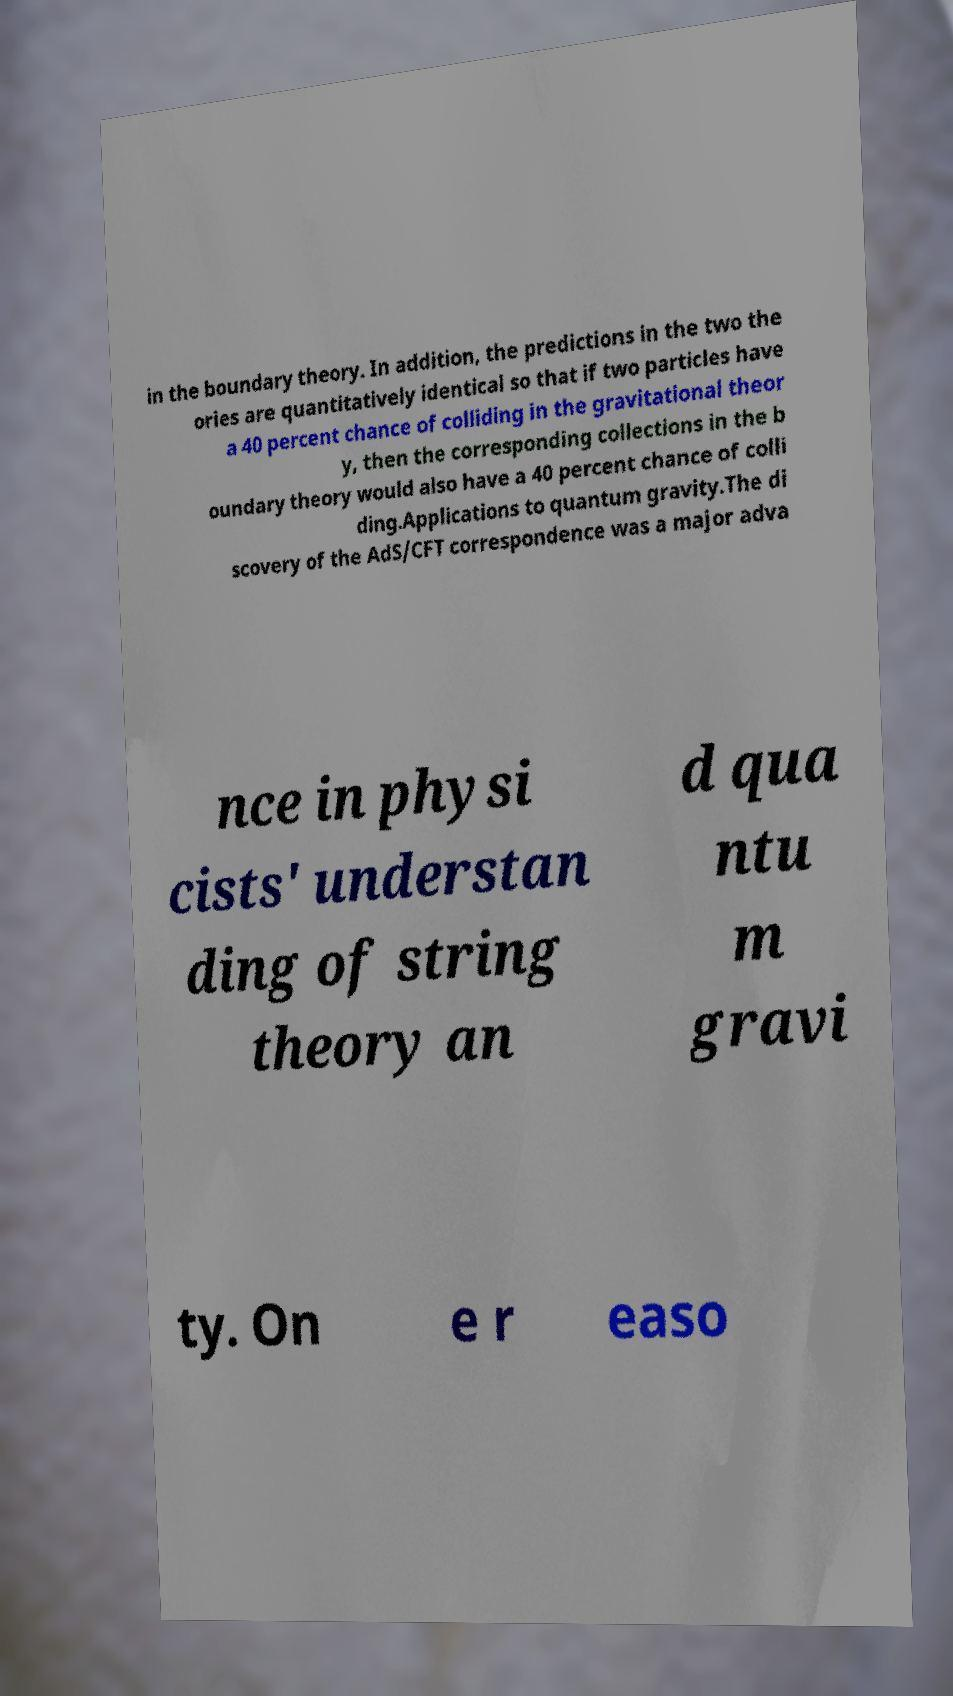Can you accurately transcribe the text from the provided image for me? in the boundary theory. In addition, the predictions in the two the ories are quantitatively identical so that if two particles have a 40 percent chance of colliding in the gravitational theor y, then the corresponding collections in the b oundary theory would also have a 40 percent chance of colli ding.Applications to quantum gravity.The di scovery of the AdS/CFT correspondence was a major adva nce in physi cists' understan ding of string theory an d qua ntu m gravi ty. On e r easo 